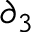Convert formula to latex. <formula><loc_0><loc_0><loc_500><loc_500>\partial _ { 3 }</formula> 